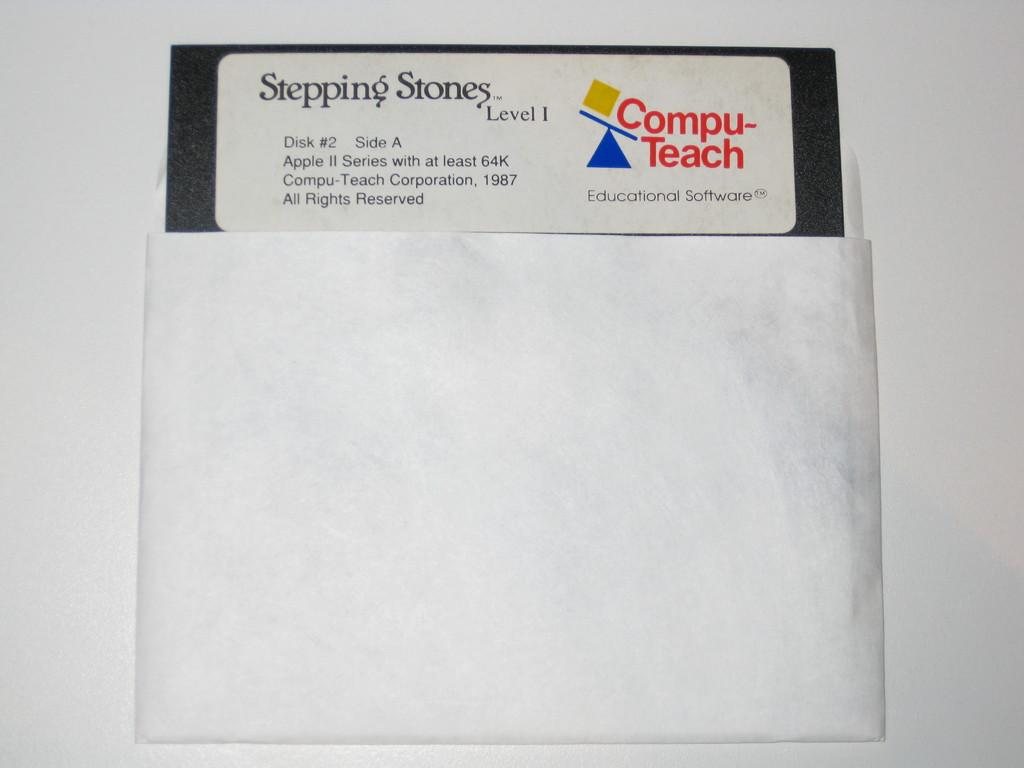Provide a one-sentence caption for the provided image. compu teach stepping stones floppy disc used for school. 